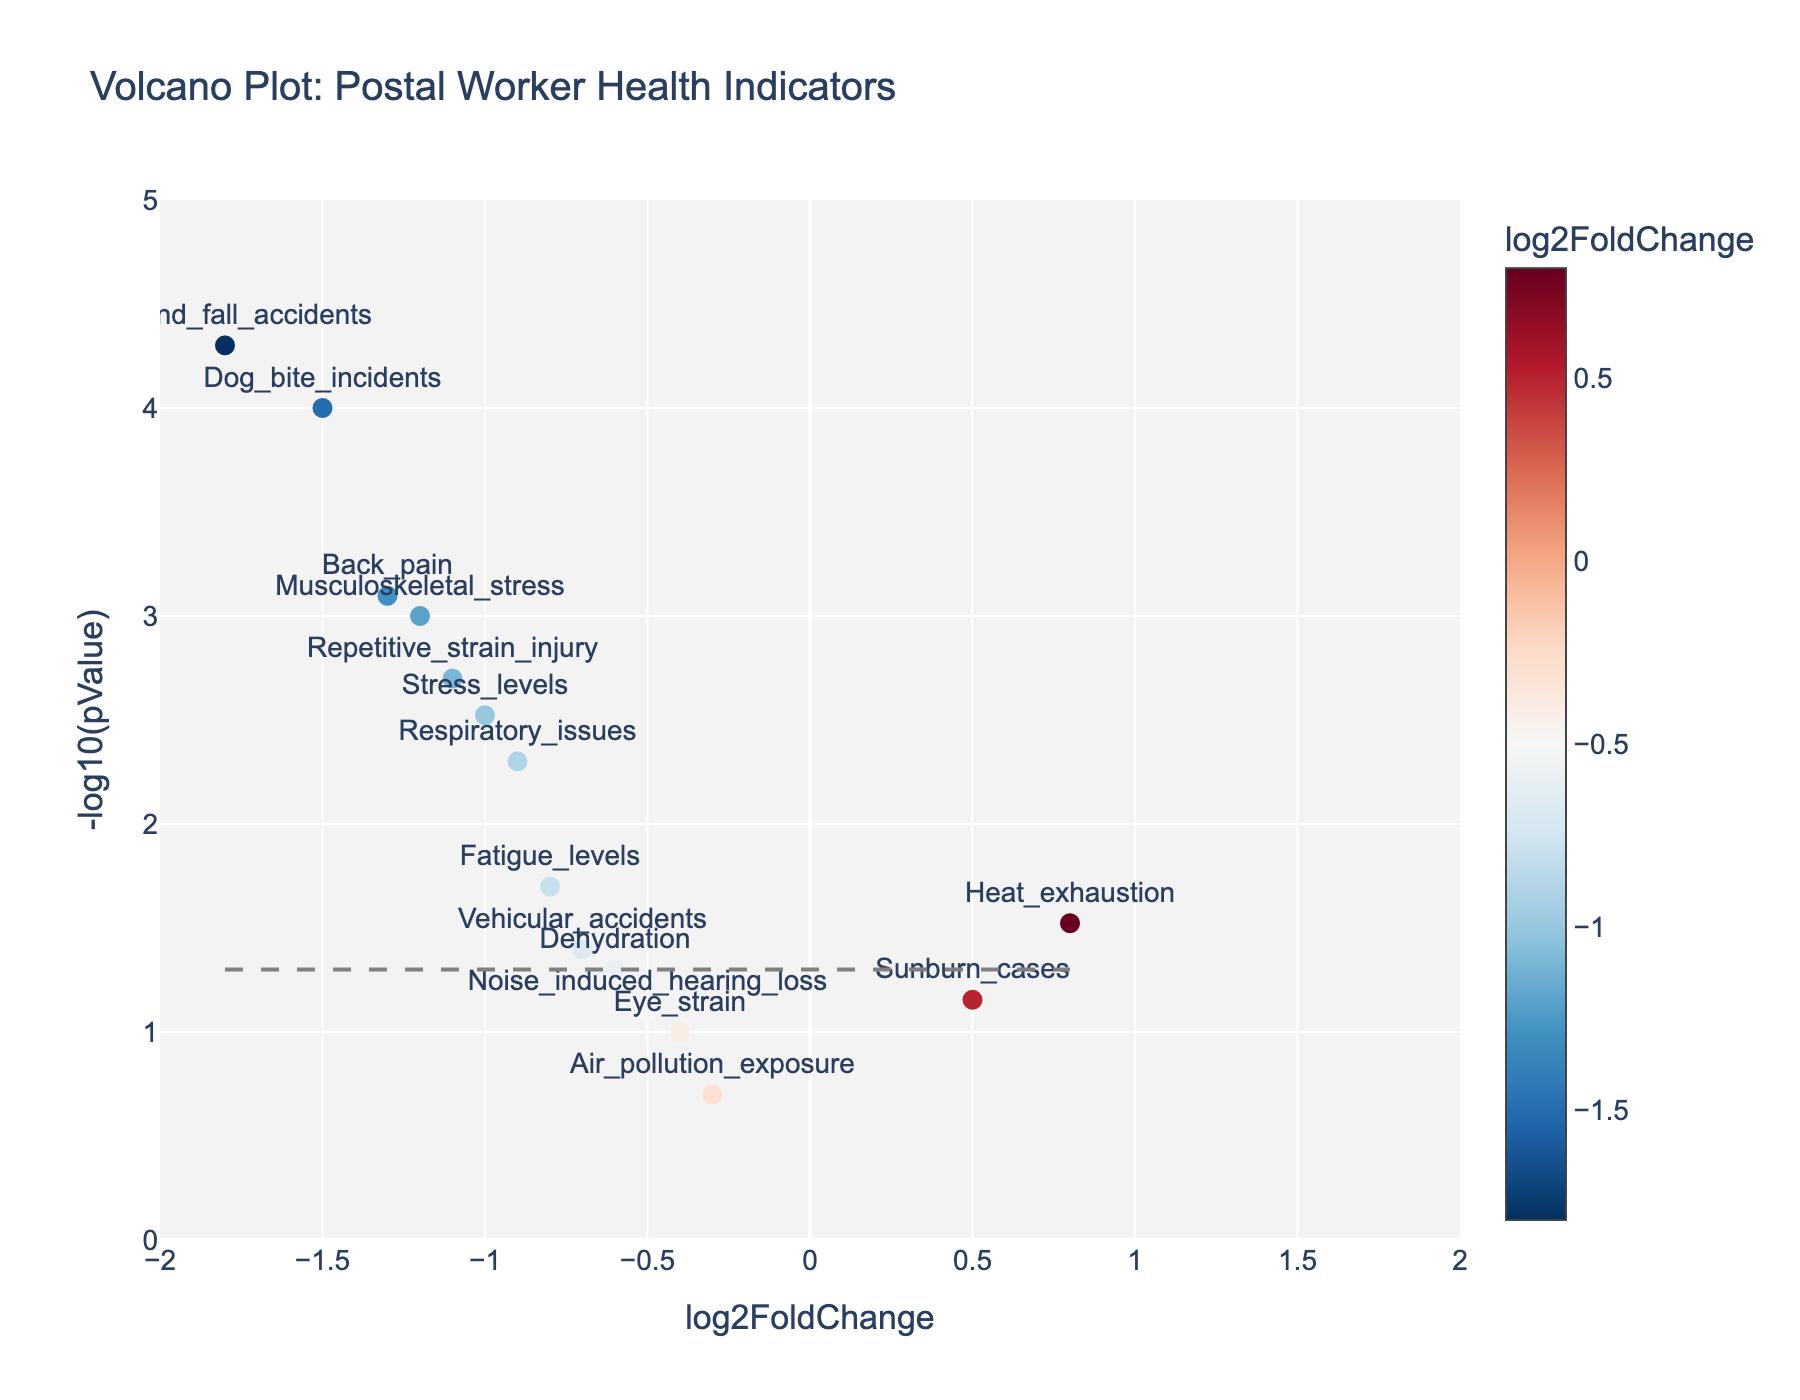What's the title of the plot? The plot's title is usually displayed prominently at the top and describes what the plot is about. In this case, it should mention "Volcano Plot" and give context about the health indicators of postal workers.
Answer: Volcano Plot: Postal Worker Health Indicators What do the x-axis and y-axis represent? The x-axis represents `log2FoldChange`, which indicates the magnitude of change in health indicators before and after safety measures. The y-axis represents `-log10(pValue)`, which indicates the significance of these changes, with higher values indicating more significant changes.
Answer: log2FoldChange and -log10(pValue) Which health indicator shows the most significant decrease after the new safety measures? To find the most significant decrease, look for the health indicator with the lowest log2FoldChange value and highest -log10(pValue) value. 'Slip_and_fall_accidents' has a very low log2FoldChange of -1.8 and a very high -log10(pValue).
Answer: Slip_and_fall_accidents Which health indicator increased the most after implementing new safety measures? To determine the biggest increase, look for the highest log2FoldChange value among the health indicators. 'Heat_exhaustion' has the highest log2FoldChange value of 0.8.
Answer: Heat_exhaustion What is the p-value threshold depicted by the horizontal line? The horizontal line is drawn at a specific -log10(pValue) value that corresponds to a p-value of 0.05. To determine this, convert -log10(0.05). The line is at approximately 1.301.
Answer: 0.05 How many health indicators show a significant change (p-value < 0.05)? Significant changes are indicated by -log10(pValue) values above 1.301 (-log10 of 0.05). Count the data points above this threshold. There are 9 indicators above this line.
Answer: 9 Which health indicators are not significantly affected by the new safety measures? Look for health indicators with a -log10(pValue) below the threshold of 1.301. 'Sunburn_cases', 'Eye_strain', 'Air_pollution_exposure', and 'Noise_induced_hearing_loss' are below this threshold.
Answer: Sunburn_cases, Eye_strain, Air_pollution_exposure, Noise_induced_hearing_loss Which health indicator has the smallest log2FoldChange? The smallest log2FoldChange represents the least change in magnitude. 'Slip_and_fall_accidents' has the lowest log2FoldChange of -1.8.
Answer: Slip_and_fall_accidents What's the ratio between the log2FoldChange of 'Musculoskeletal_stress' and 'Back_pain'? Find the log2FoldChange values of 'Musculoskeletal_stress' and 'Back_pain', then compute the ratio: -1.2 / -1.3 = 0.92.
Answer: 0.92 